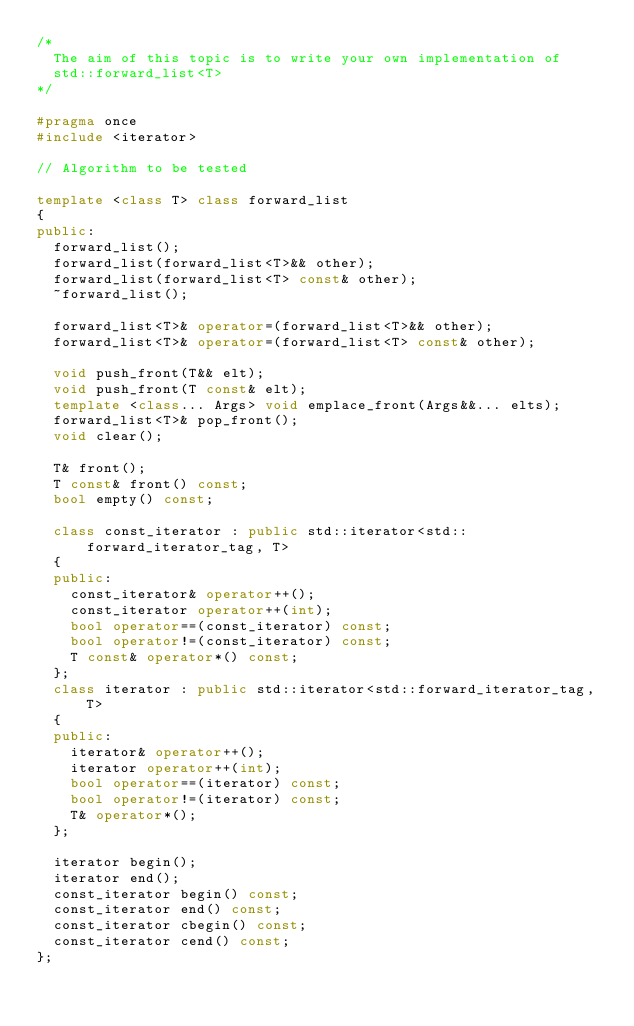Convert code to text. <code><loc_0><loc_0><loc_500><loc_500><_C++_>/*
  The aim of this topic is to write your own implementation of
  std::forward_list<T>
*/

#pragma once
#include <iterator>

// Algorithm to be tested

template <class T> class forward_list
{
public:
  forward_list();
  forward_list(forward_list<T>&& other);
  forward_list(forward_list<T> const& other);
  ~forward_list();
  
  forward_list<T>& operator=(forward_list<T>&& other);
  forward_list<T>& operator=(forward_list<T> const& other);
  
  void push_front(T&& elt);
  void push_front(T const& elt);
  template <class... Args> void emplace_front(Args&&... elts);
  forward_list<T>& pop_front();
  void clear();
  
  T& front();
  T const& front() const;
  bool empty() const;
  
  class const_iterator : public std::iterator<std::forward_iterator_tag, T>
  {
  public:
    const_iterator& operator++();
    const_iterator operator++(int);
    bool operator==(const_iterator) const;
    bool operator!=(const_iterator) const;
    T const& operator*() const;
  };
  class iterator : public std::iterator<std::forward_iterator_tag, T>
  {
  public:
    iterator& operator++();
    iterator operator++(int);
    bool operator==(iterator) const;
    bool operator!=(iterator) const;
    T& operator*();
  };
  
  iterator begin();
  iterator end();
  const_iterator begin() const;
  const_iterator end() const;
  const_iterator cbegin() const;
  const_iterator cend() const;
};

</code> 